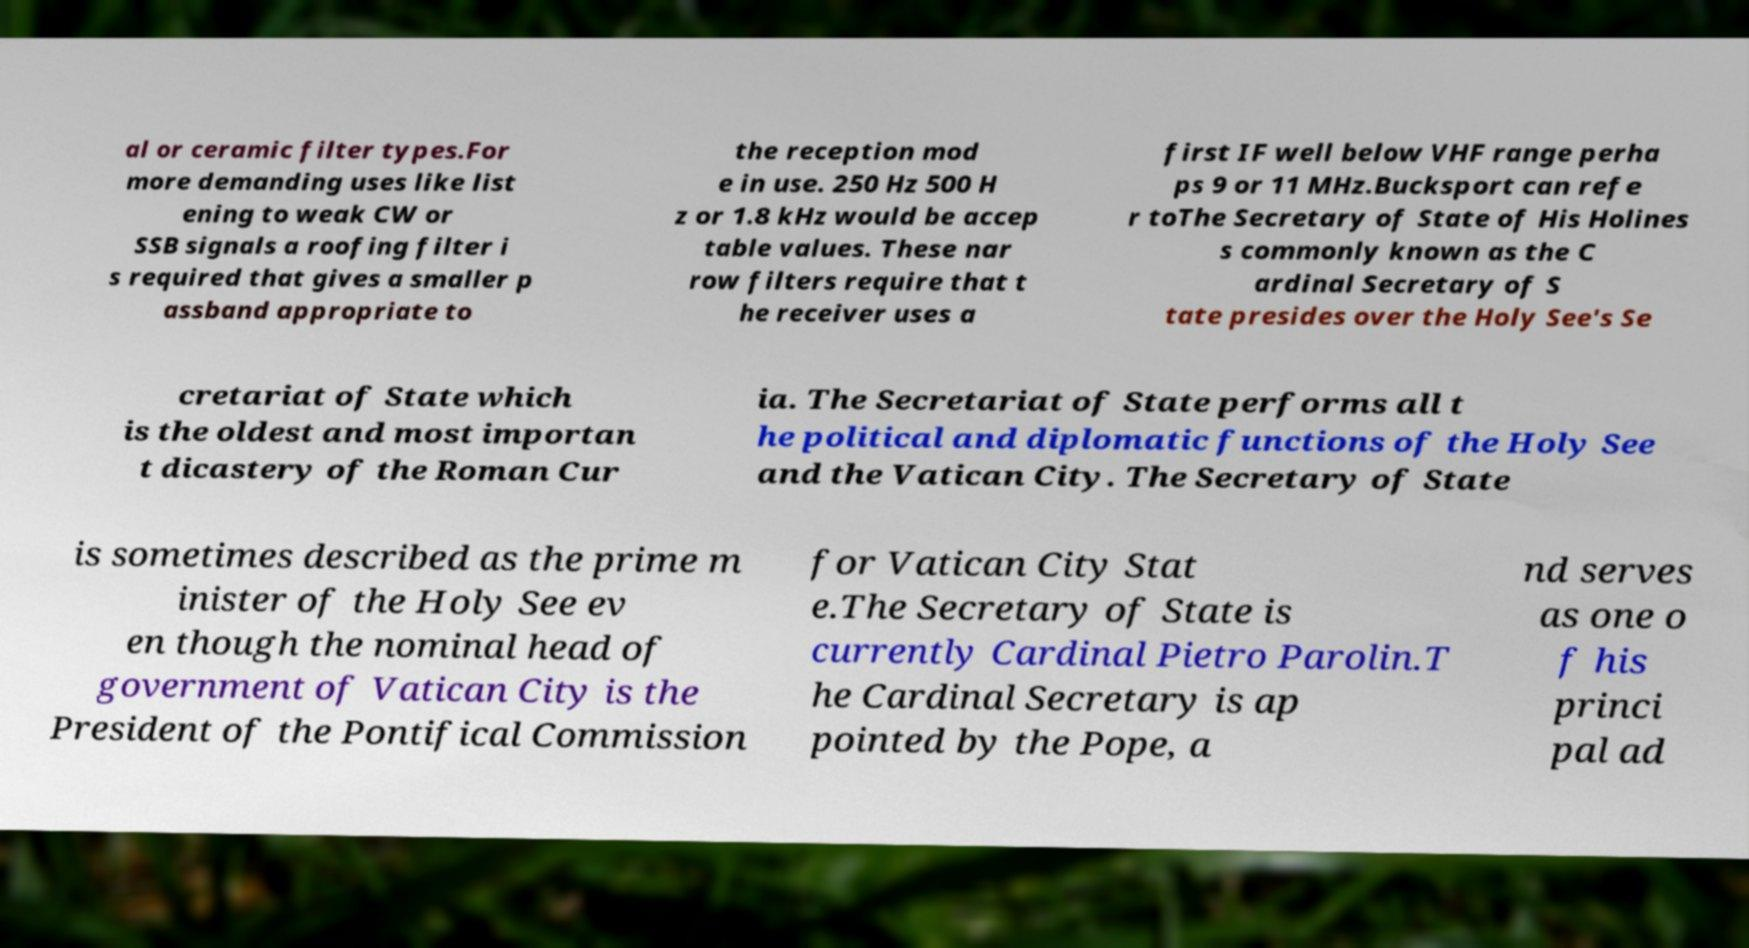Can you read and provide the text displayed in the image?This photo seems to have some interesting text. Can you extract and type it out for me? al or ceramic filter types.For more demanding uses like list ening to weak CW or SSB signals a roofing filter i s required that gives a smaller p assband appropriate to the reception mod e in use. 250 Hz 500 H z or 1.8 kHz would be accep table values. These nar row filters require that t he receiver uses a first IF well below VHF range perha ps 9 or 11 MHz.Bucksport can refe r toThe Secretary of State of His Holines s commonly known as the C ardinal Secretary of S tate presides over the Holy See's Se cretariat of State which is the oldest and most importan t dicastery of the Roman Cur ia. The Secretariat of State performs all t he political and diplomatic functions of the Holy See and the Vatican City. The Secretary of State is sometimes described as the prime m inister of the Holy See ev en though the nominal head of government of Vatican City is the President of the Pontifical Commission for Vatican City Stat e.The Secretary of State is currently Cardinal Pietro Parolin.T he Cardinal Secretary is ap pointed by the Pope, a nd serves as one o f his princi pal ad 